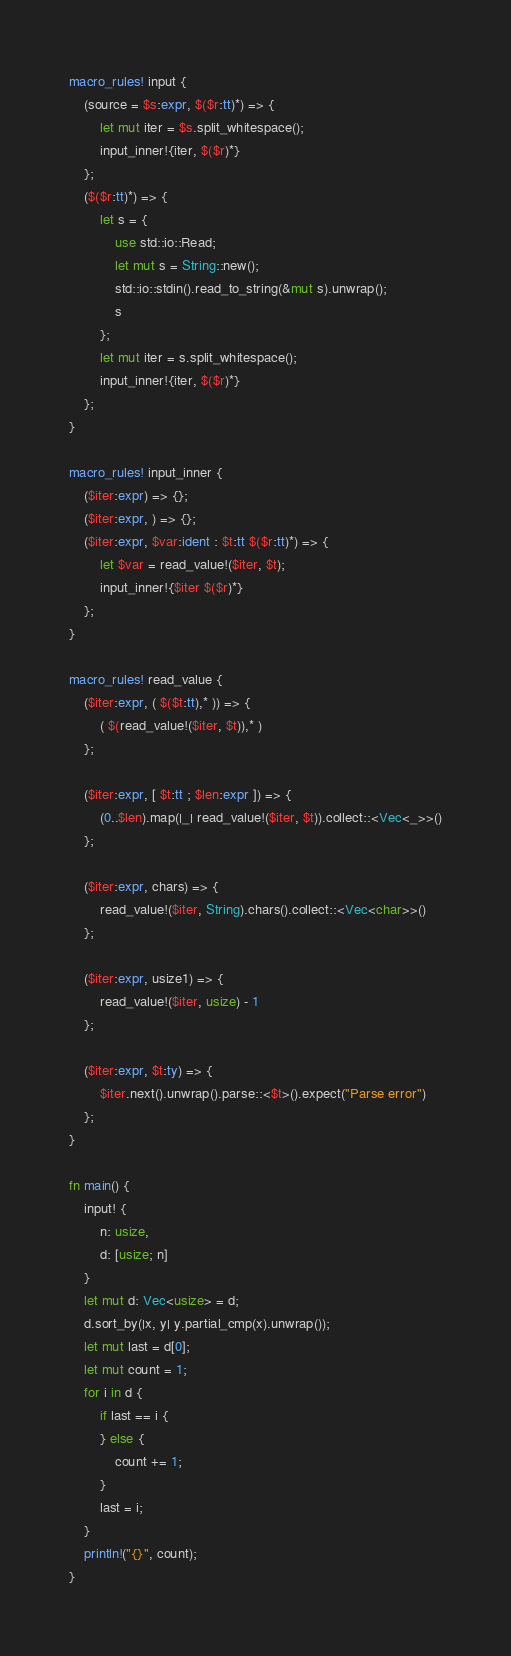<code> <loc_0><loc_0><loc_500><loc_500><_Rust_>macro_rules! input {
    (source = $s:expr, $($r:tt)*) => {
        let mut iter = $s.split_whitespace();
        input_inner!{iter, $($r)*}
    };
    ($($r:tt)*) => {
        let s = {
            use std::io::Read;
            let mut s = String::new();
            std::io::stdin().read_to_string(&mut s).unwrap();
            s
        };
        let mut iter = s.split_whitespace();
        input_inner!{iter, $($r)*}
    };
}

macro_rules! input_inner {
    ($iter:expr) => {};
    ($iter:expr, ) => {};
    ($iter:expr, $var:ident : $t:tt $($r:tt)*) => {
        let $var = read_value!($iter, $t);
        input_inner!{$iter $($r)*}
    };
}

macro_rules! read_value {
    ($iter:expr, ( $($t:tt),* )) => {
        ( $(read_value!($iter, $t)),* )
    };

    ($iter:expr, [ $t:tt ; $len:expr ]) => {
        (0..$len).map(|_| read_value!($iter, $t)).collect::<Vec<_>>()
    };

    ($iter:expr, chars) => {
        read_value!($iter, String).chars().collect::<Vec<char>>()
    };

    ($iter:expr, usize1) => {
        read_value!($iter, usize) - 1
    };

    ($iter:expr, $t:ty) => {
        $iter.next().unwrap().parse::<$t>().expect("Parse error")
    };
}

fn main() {
    input! {
        n: usize,
        d: [usize; n]
    }
    let mut d: Vec<usize> = d;
    d.sort_by(|x, y| y.partial_cmp(x).unwrap());
    let mut last = d[0];
    let mut count = 1;
    for i in d {
        if last == i {
        } else {
            count += 1;
        }
        last = i;
    }
    println!("{}", count);
}
</code> 